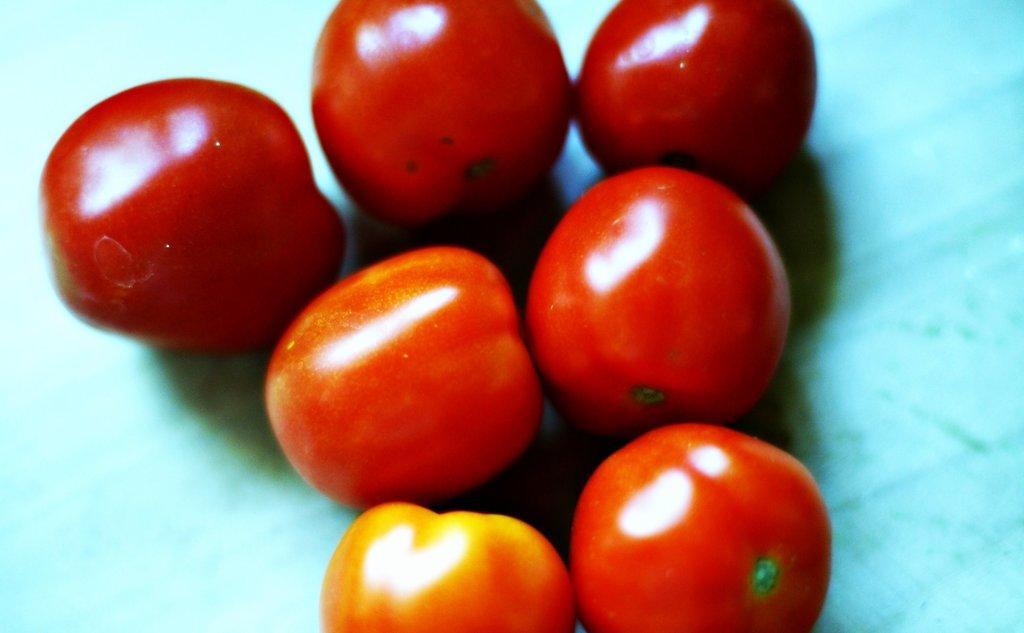How would you summarize this image in a sentence or two? In the middle of this image, there are seven tomatoes arranged on a surface. And the background is blue in color. 